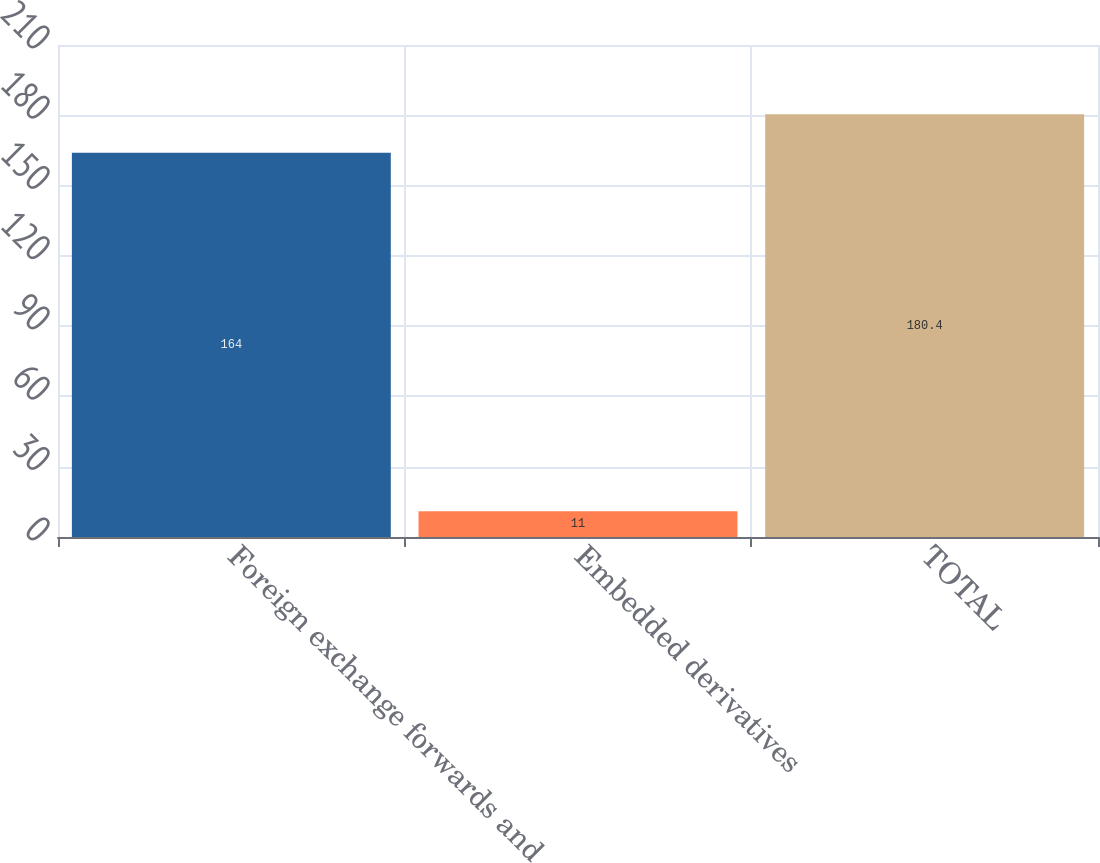<chart> <loc_0><loc_0><loc_500><loc_500><bar_chart><fcel>Foreign exchange forwards and<fcel>Embedded derivatives<fcel>TOTAL<nl><fcel>164<fcel>11<fcel>180.4<nl></chart> 